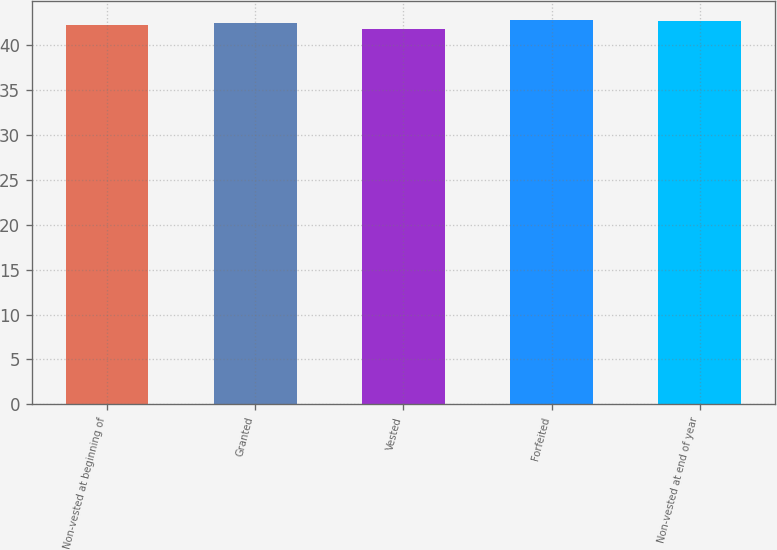<chart> <loc_0><loc_0><loc_500><loc_500><bar_chart><fcel>Non-vested at beginning of<fcel>Granted<fcel>Vested<fcel>Forfeited<fcel>Non-vested at end of year<nl><fcel>42.27<fcel>42.44<fcel>41.79<fcel>42.83<fcel>42.73<nl></chart> 